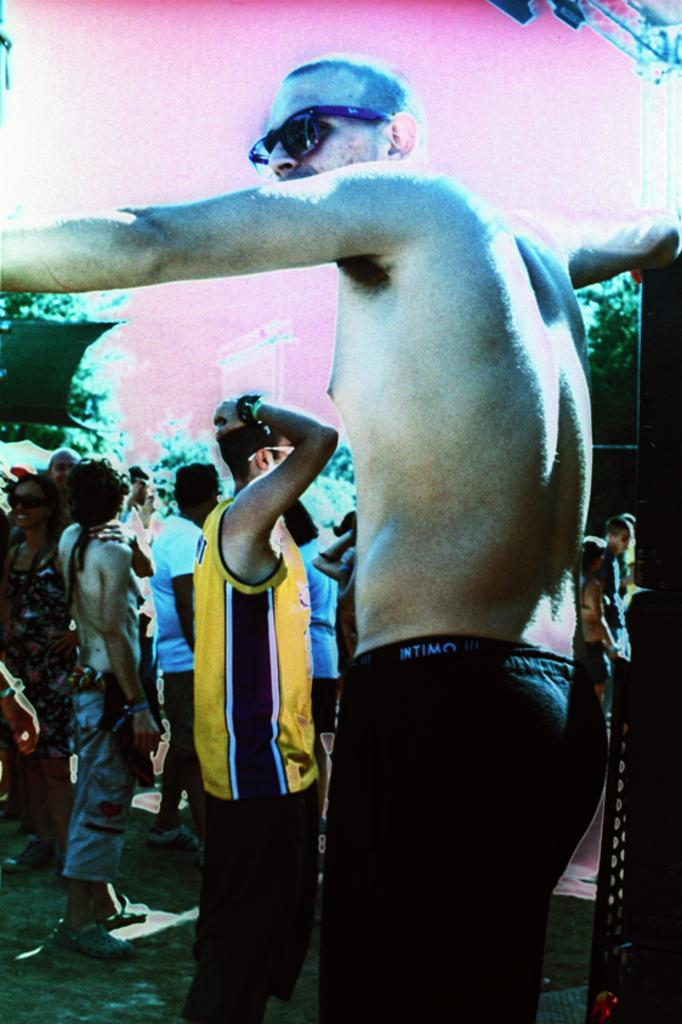What is the main subject of the image? There is a person standing in the image. What is the person wearing? The person is wearing black pants. Are there any other people in the image? Yes, there are other people standing behind the person. What can be seen in the background of the image? There are trees visible in the background, and the background has a pink color. Can you tell me how many snakes are wrapped around the person's legs in the image? There are no snakes present in the image; the person is standing alone. Is the person's family visible in the image? The facts provided do not mention the person's family, so we cannot determine if they are visible in the image. 